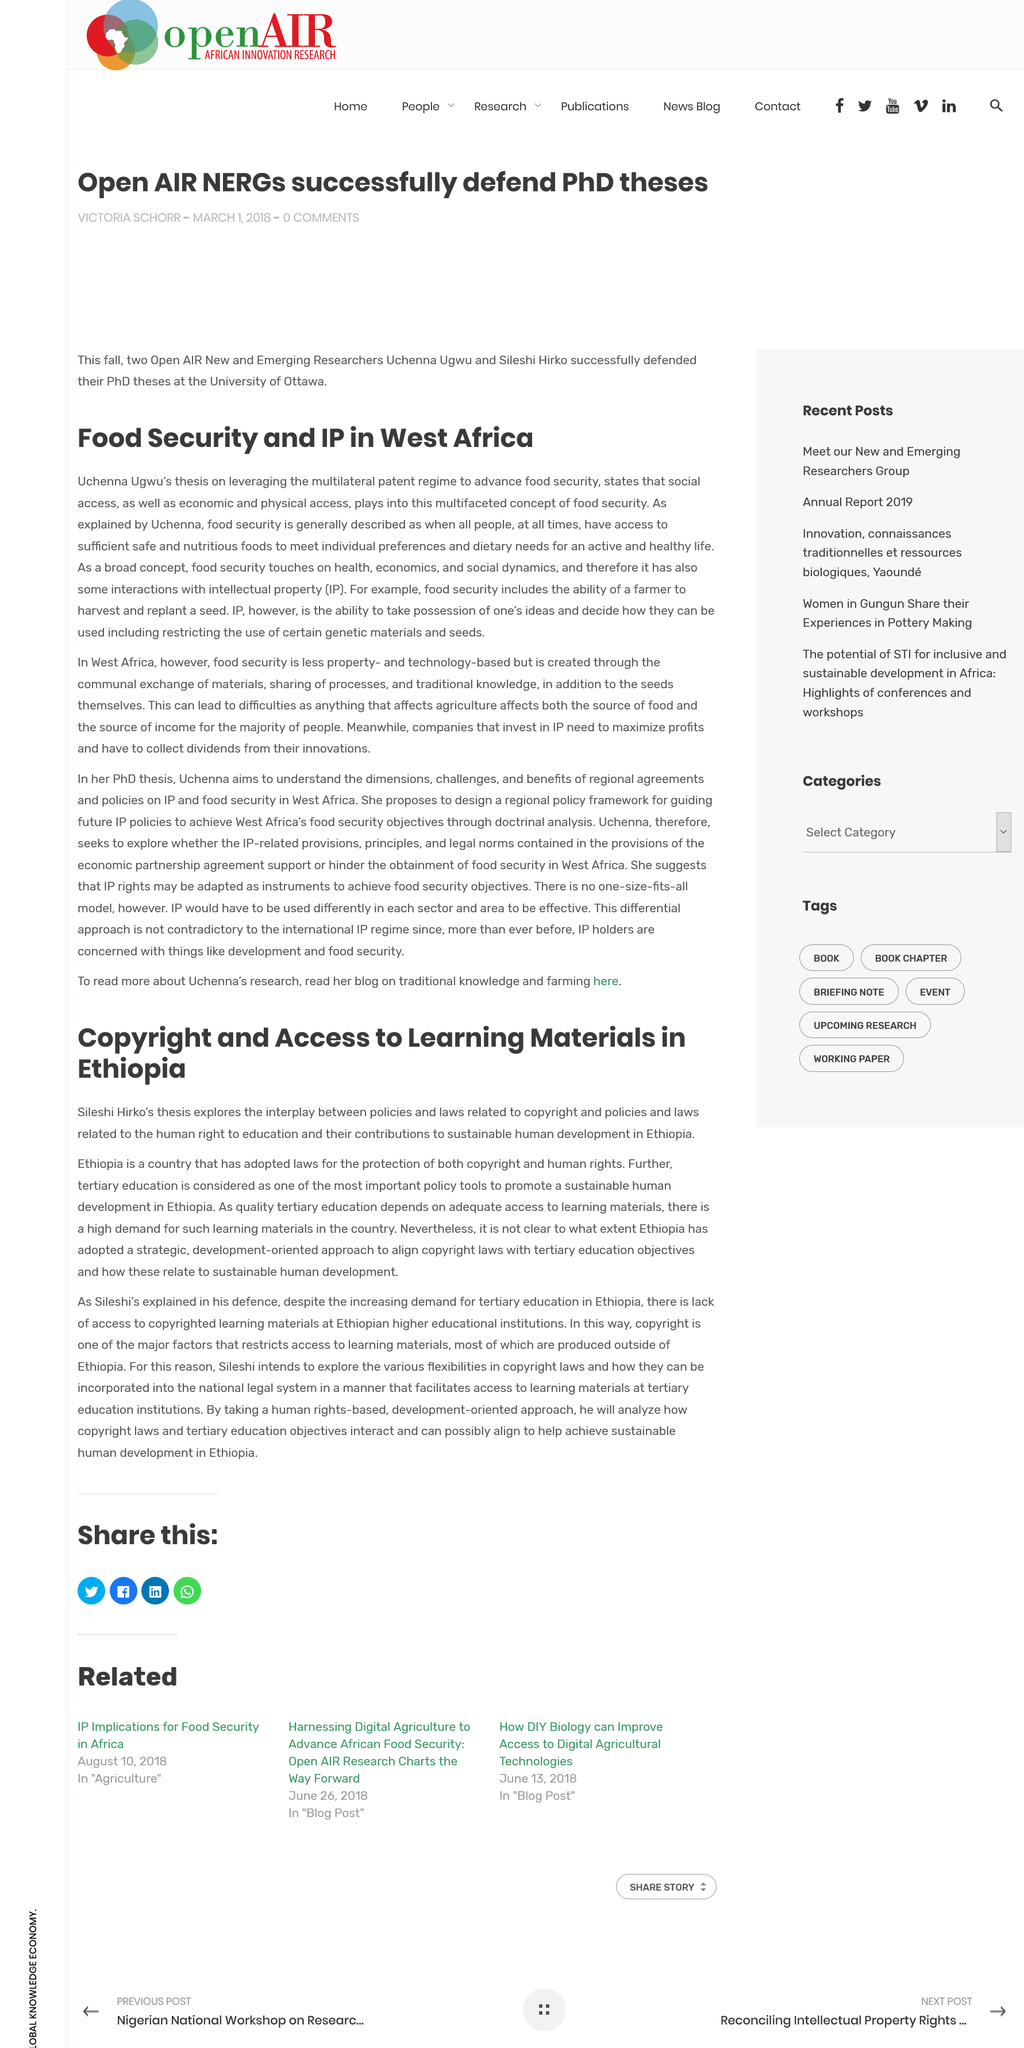Indicate a few pertinent items in this graphic. The person whose thesis on leveraging the multilateral patent regime states that social access plays into the multifaceted concept of food security is Uchenna Ugwu. Yes, food security includes the ability of a farmer to harvest and replant a seed. Sileshi Hirko's thesis explores the interplay between policies and laws related to copyright and laws in Ethiopia, providing a comprehensive analysis of the relationship between these two areas of law and their impact on the creative industry in Ethiopia. The quality of tertiary education is heavily dependent on access to adequate learning materials. The main focus of this article is on the issue of copyright and access to learning materials in Ethiopia. 